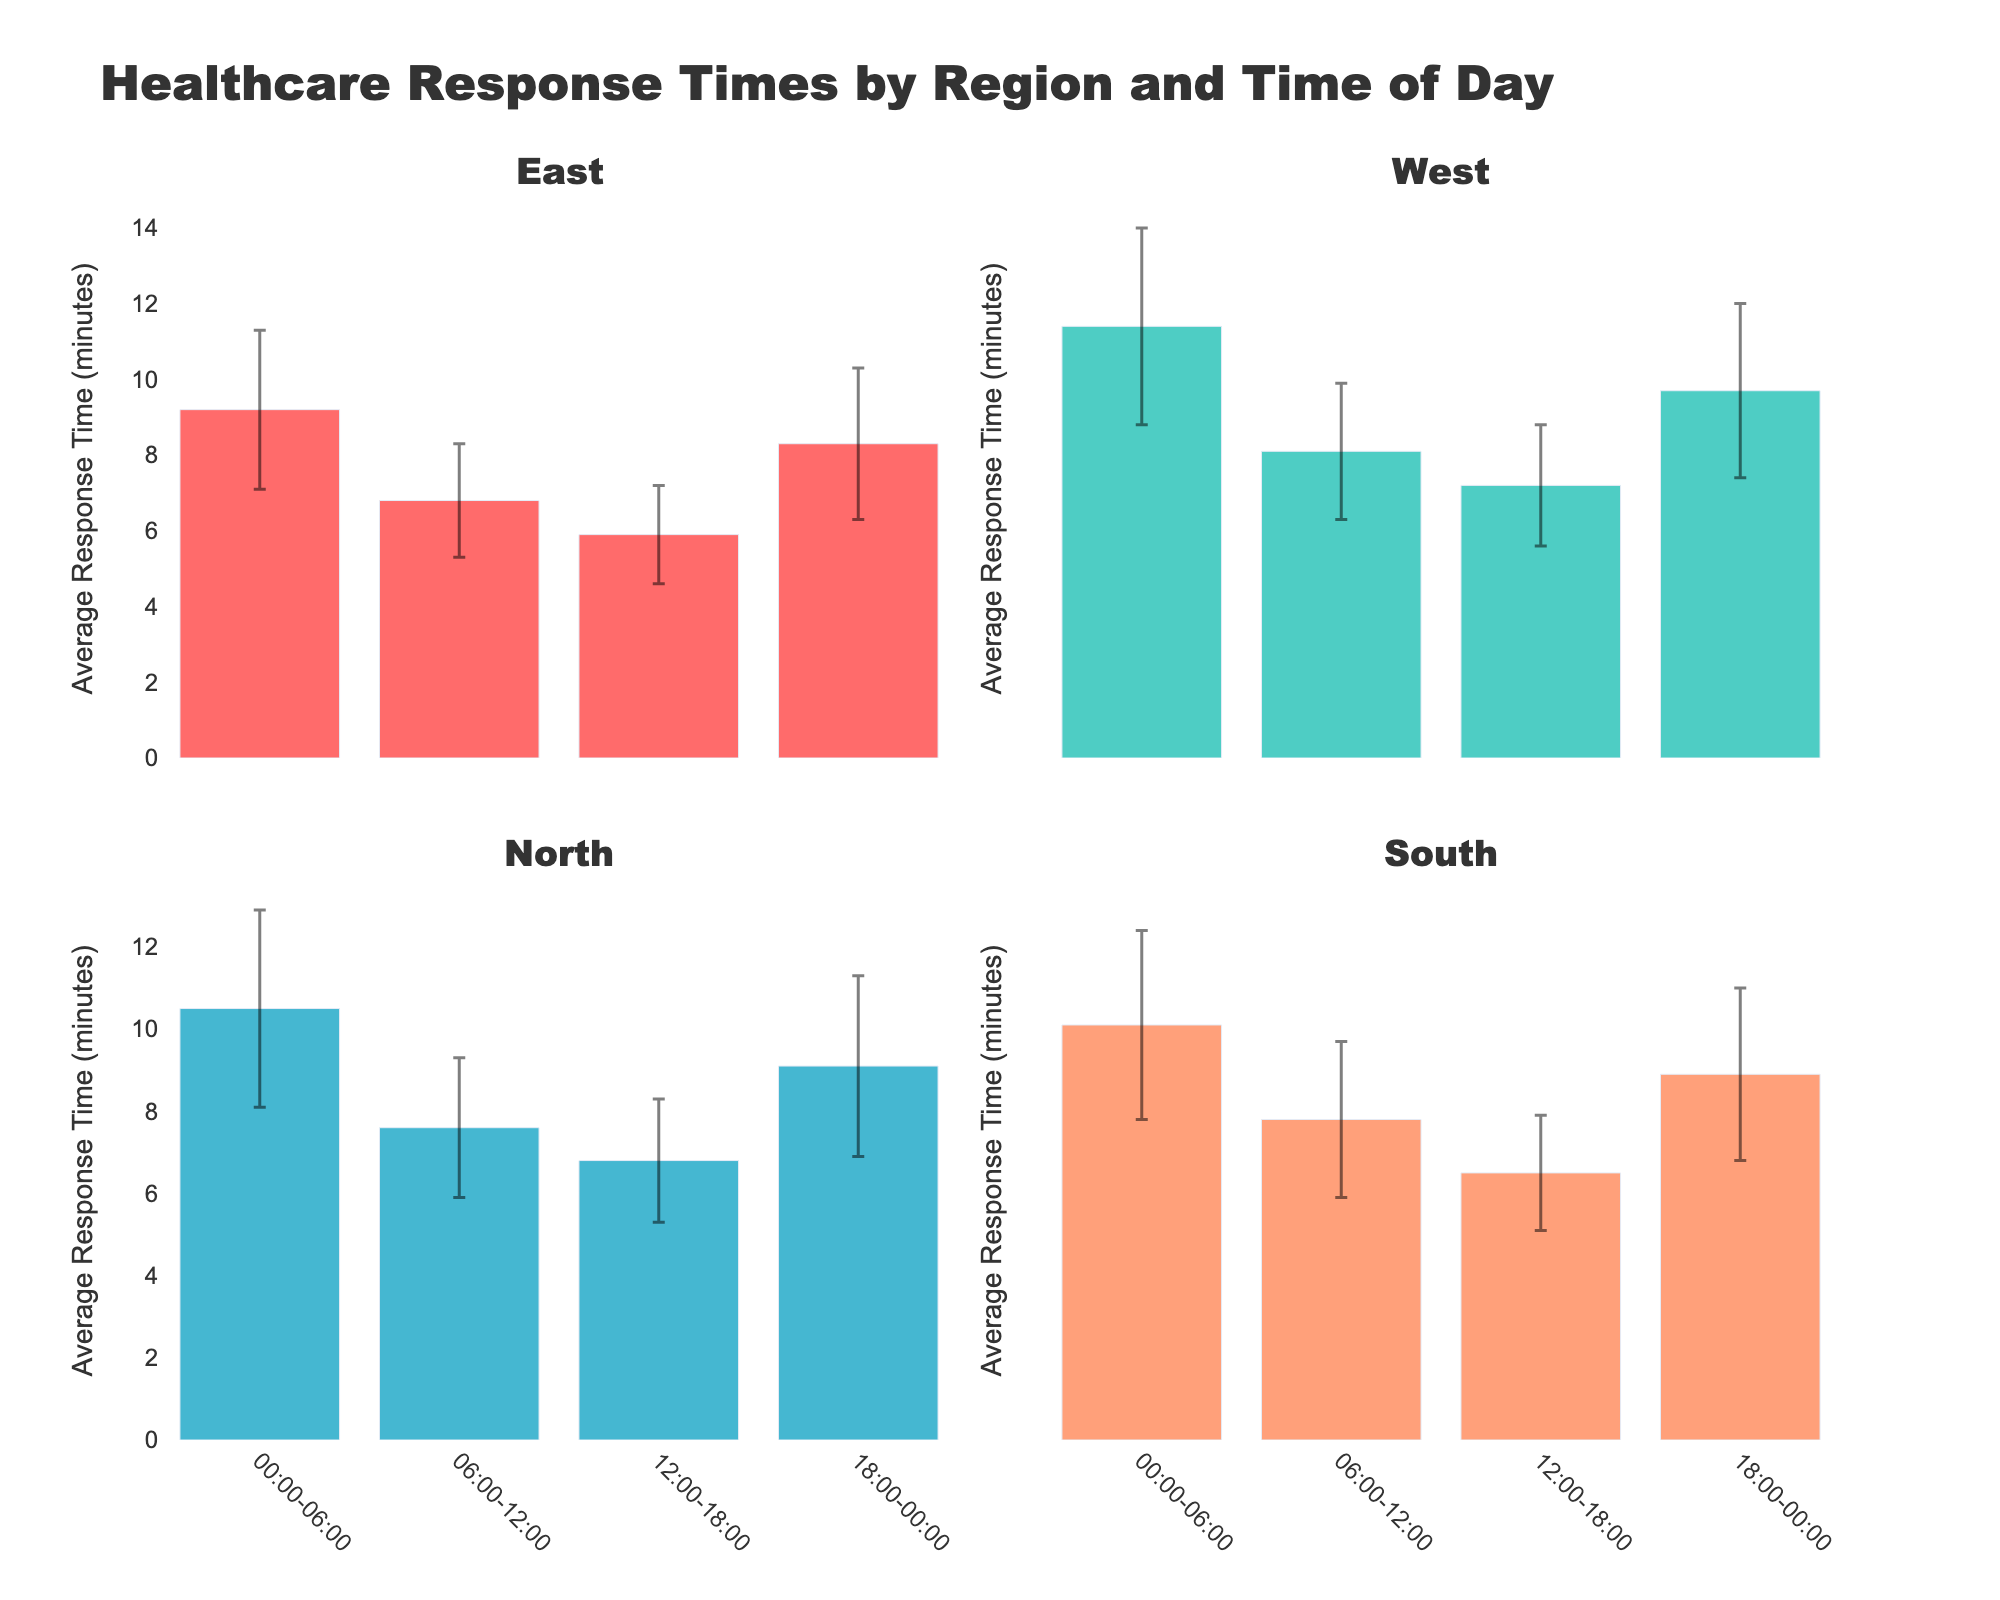What's the title of the figure? The title is usually located at the top of the figure and summarizes the main information. Just look at the top part of the image.
Answer: Healthcare Response Times by Region and Time of Day How many time slots are compared for each region? The figure divides each region into specific time slots, usually displayed on the x-axis. Count the number of these segments for one region.
Answer: 4 Which region has the highest average response time in the 00:00-06:00 time slot? Look at the bar heights in the 00:00-06:00 time slot for all regions and identify the tallest one.
Answer: West What is the approximate average response time in the East region between 12:00-18:00? Locate the bar for the East region in the 12:00-18:00 slot and estimate its height using the y-axis scale.
Answer: 5.9 minutes Which region has the lowest average response time in any time slot? Identify the shortest bar in any time slot across all regions and check which region it belongs to.
Answer: East (12:00-18:00) Which region shows the largest variation in response times throughout the day? Evaluate the error bars for each region's data. The region with the largest variations (longest error bars) indicates higher inconsistency.
Answer: West Compare the average response times between East and North in the 18:00-00:00 slot. Look at the bars for East and North for the 18:00-00:00 time slot and compare their heights.
Answer: East: 8.3, North: 9.1 What is the difference in average response times between the South region's 00:00-06:00 and 12:00-18:00 time slots? Find the response times for the South region in the specified time slots and subtract the smaller value from the larger one.
Answer: 10.1 - 6.5 = 3.6 minutes Are there any time slots where all regions have nearly the same average response times? Scan through the bars across all time slots and look for a time slot where all the bars have similar heights.
Answer: No How do the response times in the West region vary throughout the day? Look at the bars for the West region across all time slots and note the changes in height.
Answer: They are higher at night (00:00-06:00 and 18:00-00:00) and lower during the day (06:00-18:00) 